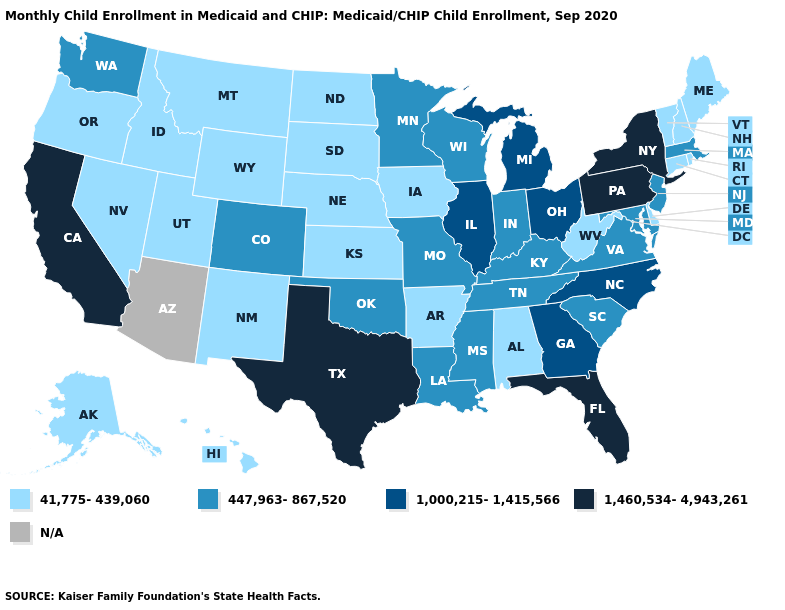What is the highest value in the West ?
Give a very brief answer. 1,460,534-4,943,261. Does the map have missing data?
Be succinct. Yes. Name the states that have a value in the range 447,963-867,520?
Concise answer only. Colorado, Indiana, Kentucky, Louisiana, Maryland, Massachusetts, Minnesota, Mississippi, Missouri, New Jersey, Oklahoma, South Carolina, Tennessee, Virginia, Washington, Wisconsin. Which states hav the highest value in the MidWest?
Be succinct. Illinois, Michigan, Ohio. Does Oregon have the highest value in the USA?
Write a very short answer. No. What is the lowest value in states that border Arizona?
Concise answer only. 41,775-439,060. Which states hav the highest value in the MidWest?
Quick response, please. Illinois, Michigan, Ohio. What is the value of Utah?
Answer briefly. 41,775-439,060. Which states have the lowest value in the MidWest?
Give a very brief answer. Iowa, Kansas, Nebraska, North Dakota, South Dakota. Name the states that have a value in the range 41,775-439,060?
Short answer required. Alabama, Alaska, Arkansas, Connecticut, Delaware, Hawaii, Idaho, Iowa, Kansas, Maine, Montana, Nebraska, Nevada, New Hampshire, New Mexico, North Dakota, Oregon, Rhode Island, South Dakota, Utah, Vermont, West Virginia, Wyoming. What is the value of South Carolina?
Keep it brief. 447,963-867,520. Among the states that border Ohio , does Pennsylvania have the highest value?
Short answer required. Yes. What is the lowest value in the USA?
Keep it brief. 41,775-439,060. What is the value of New Hampshire?
Be succinct. 41,775-439,060. What is the value of Kansas?
Write a very short answer. 41,775-439,060. 